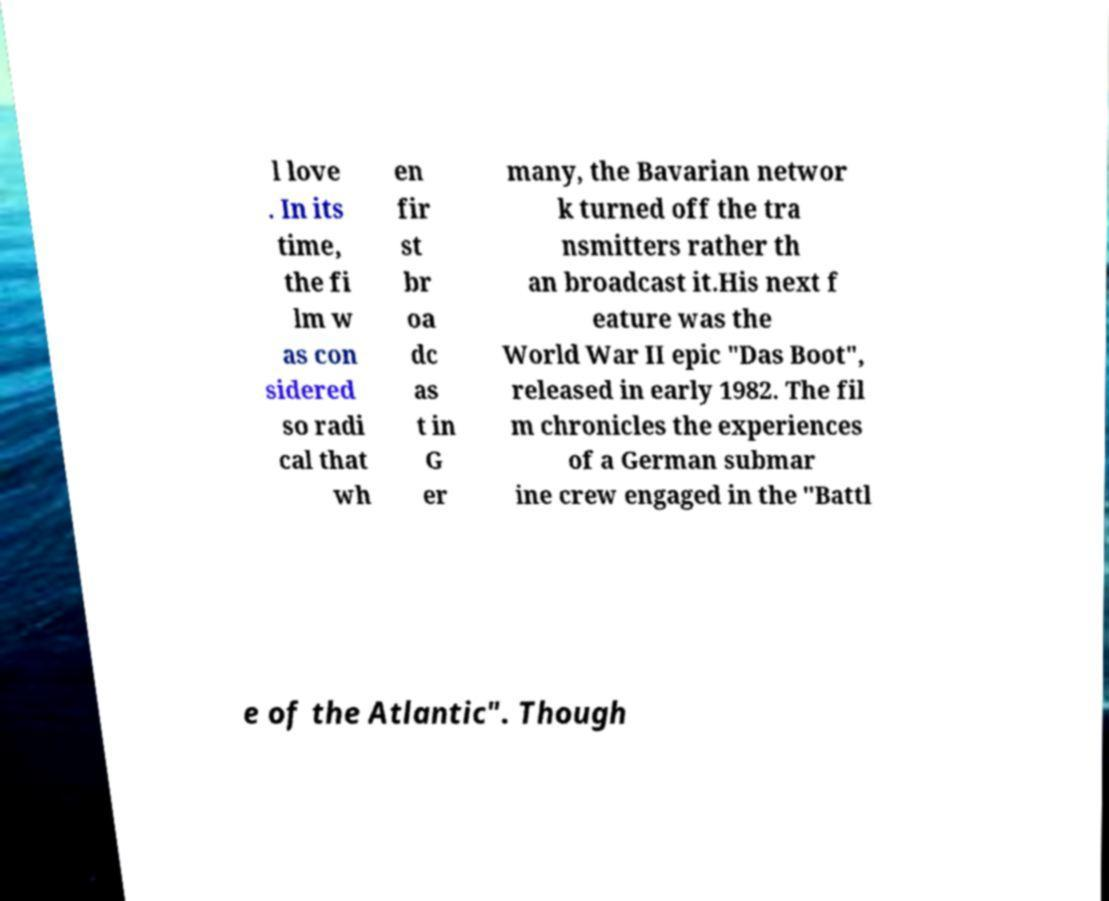Please read and relay the text visible in this image. What does it say? l love . In its time, the fi lm w as con sidered so radi cal that wh en fir st br oa dc as t in G er many, the Bavarian networ k turned off the tra nsmitters rather th an broadcast it.His next f eature was the World War II epic "Das Boot", released in early 1982. The fil m chronicles the experiences of a German submar ine crew engaged in the "Battl e of the Atlantic". Though 